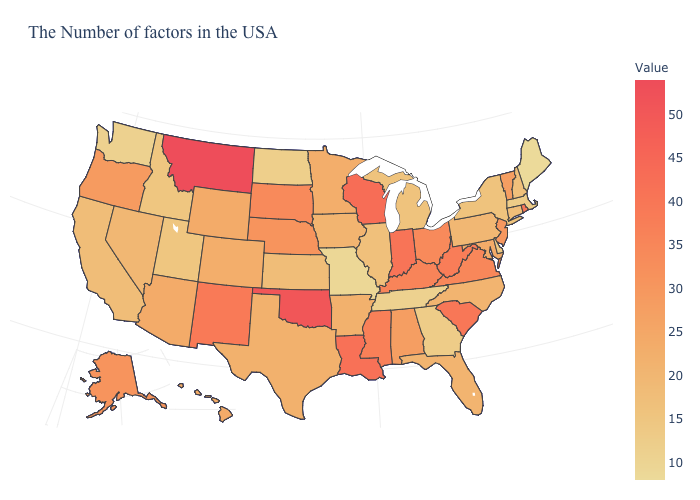Which states have the highest value in the USA?
Short answer required. Montana. Which states have the lowest value in the MidWest?
Short answer required. Missouri. Which states have the lowest value in the West?
Concise answer only. Washington. Does the map have missing data?
Quick response, please. No. Does New Jersey have the lowest value in the Northeast?
Answer briefly. No. Among the states that border Wisconsin , which have the highest value?
Give a very brief answer. Minnesota. Does the map have missing data?
Answer briefly. No. Does the map have missing data?
Concise answer only. No. 